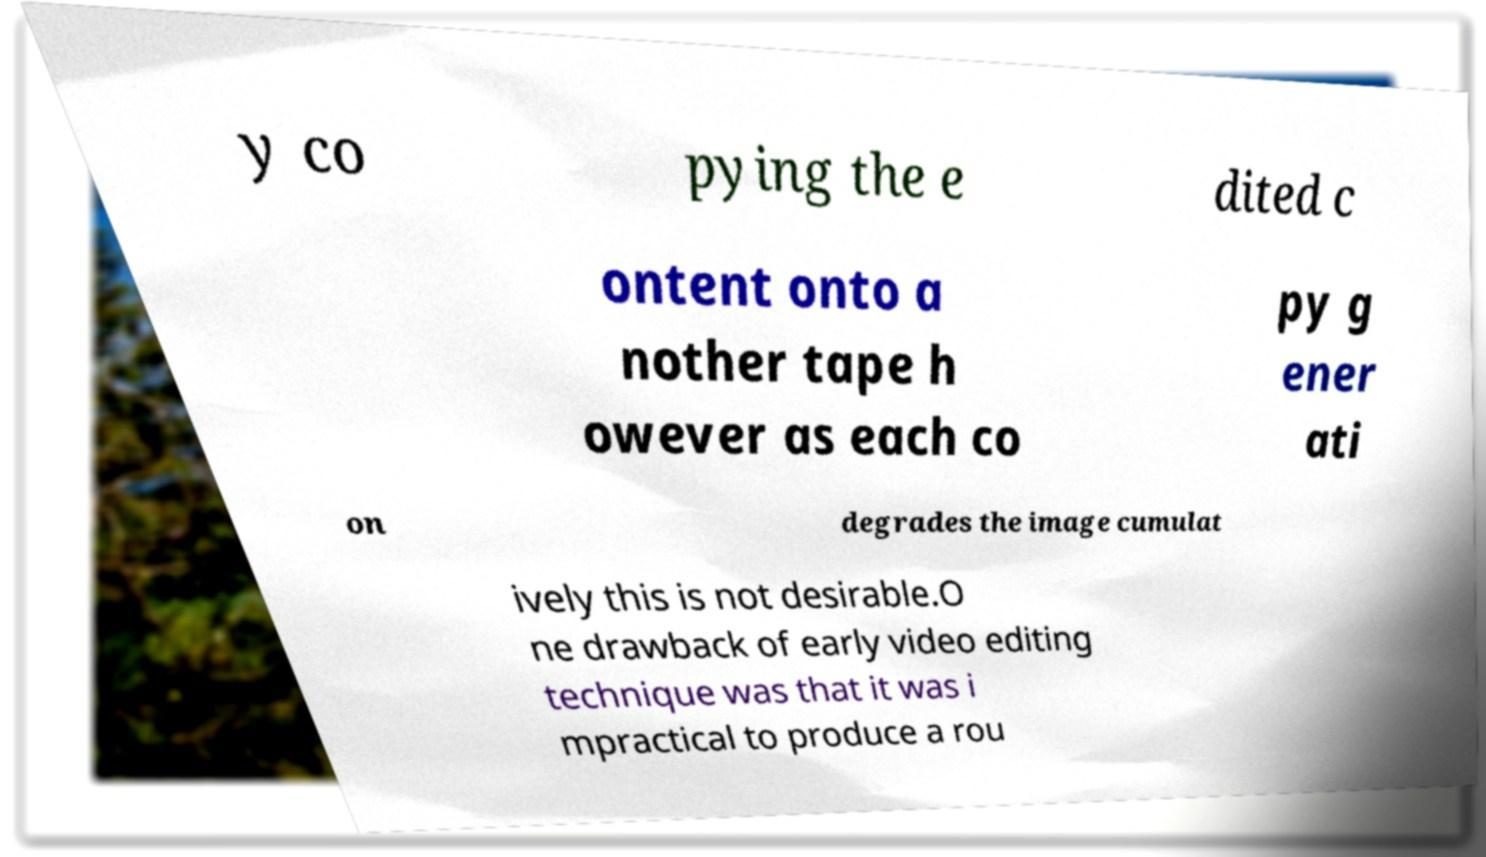What messages or text are displayed in this image? I need them in a readable, typed format. y co pying the e dited c ontent onto a nother tape h owever as each co py g ener ati on degrades the image cumulat ively this is not desirable.O ne drawback of early video editing technique was that it was i mpractical to produce a rou 